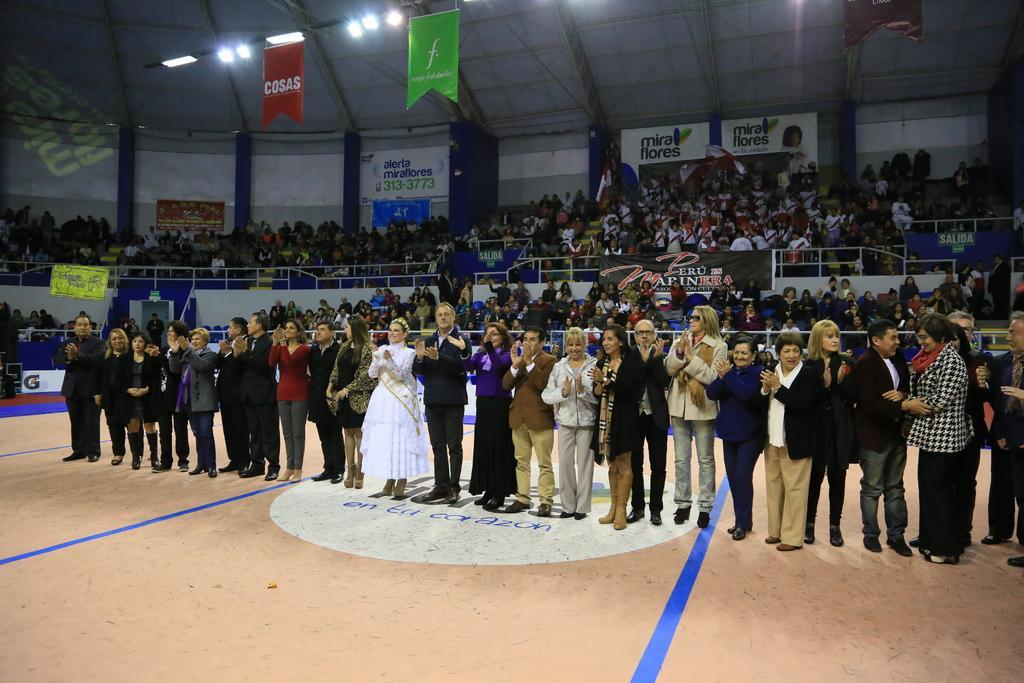Can you describe this image briefly? In this picture we can see some people standing on the ground and in the background we can see a fence, group of people, banners, posters, lights, roof and some objects. 